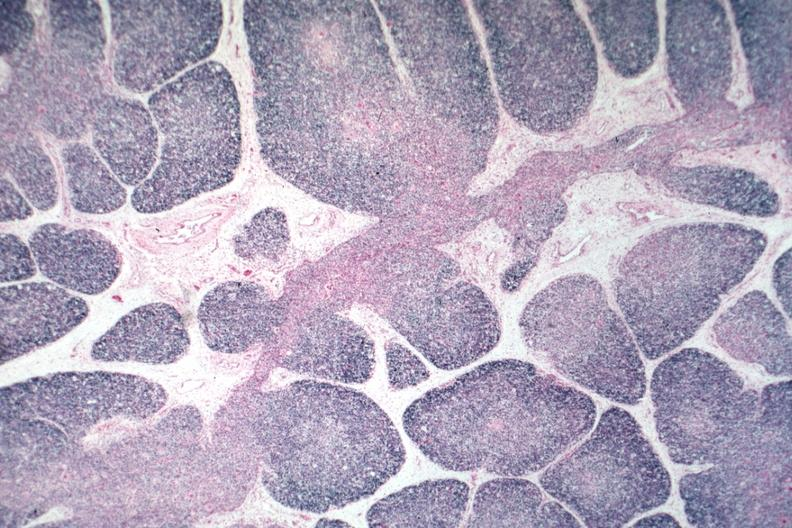s thymus present?
Answer the question using a single word or phrase. Yes 